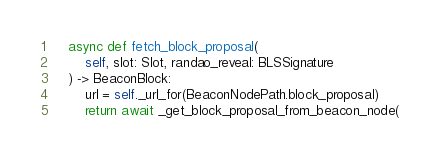Convert code to text. <code><loc_0><loc_0><loc_500><loc_500><_Python_>
    async def fetch_block_proposal(
        self, slot: Slot, randao_reveal: BLSSignature
    ) -> BeaconBlock:
        url = self._url_for(BeaconNodePath.block_proposal)
        return await _get_block_proposal_from_beacon_node(</code> 